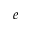<formula> <loc_0><loc_0><loc_500><loc_500>e</formula> 